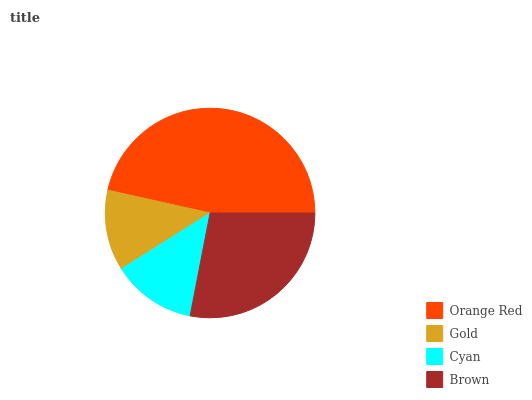Is Gold the minimum?
Answer yes or no. Yes. Is Orange Red the maximum?
Answer yes or no. Yes. Is Cyan the minimum?
Answer yes or no. No. Is Cyan the maximum?
Answer yes or no. No. Is Cyan greater than Gold?
Answer yes or no. Yes. Is Gold less than Cyan?
Answer yes or no. Yes. Is Gold greater than Cyan?
Answer yes or no. No. Is Cyan less than Gold?
Answer yes or no. No. Is Brown the high median?
Answer yes or no. Yes. Is Cyan the low median?
Answer yes or no. Yes. Is Gold the high median?
Answer yes or no. No. Is Brown the low median?
Answer yes or no. No. 